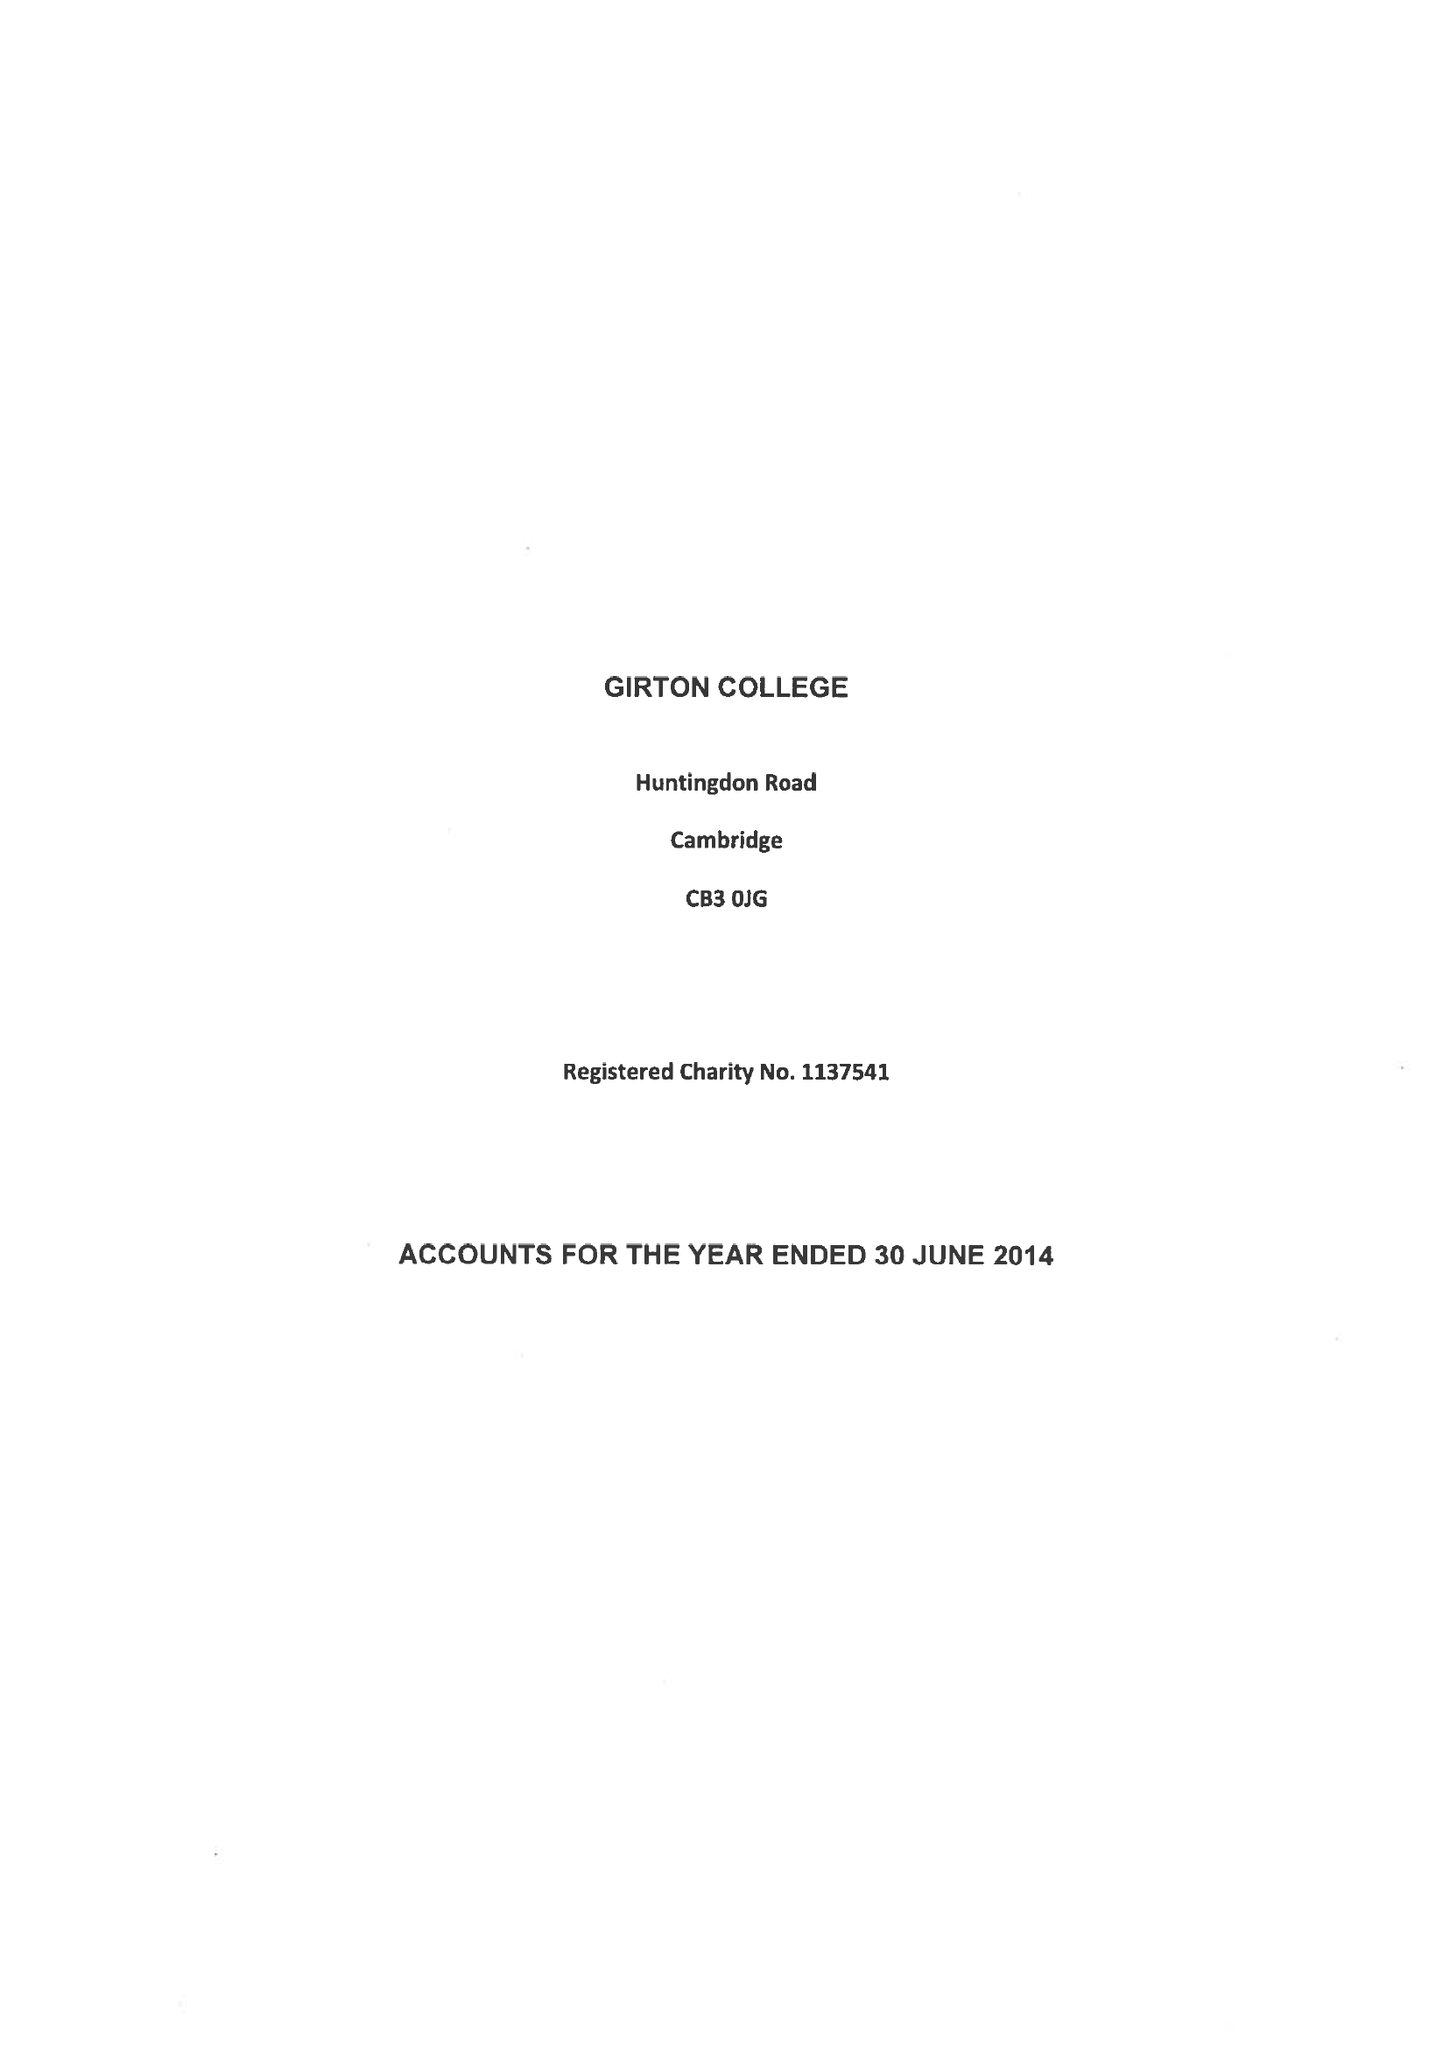What is the value for the address__post_town?
Answer the question using a single word or phrase. CAMBRIDGE 